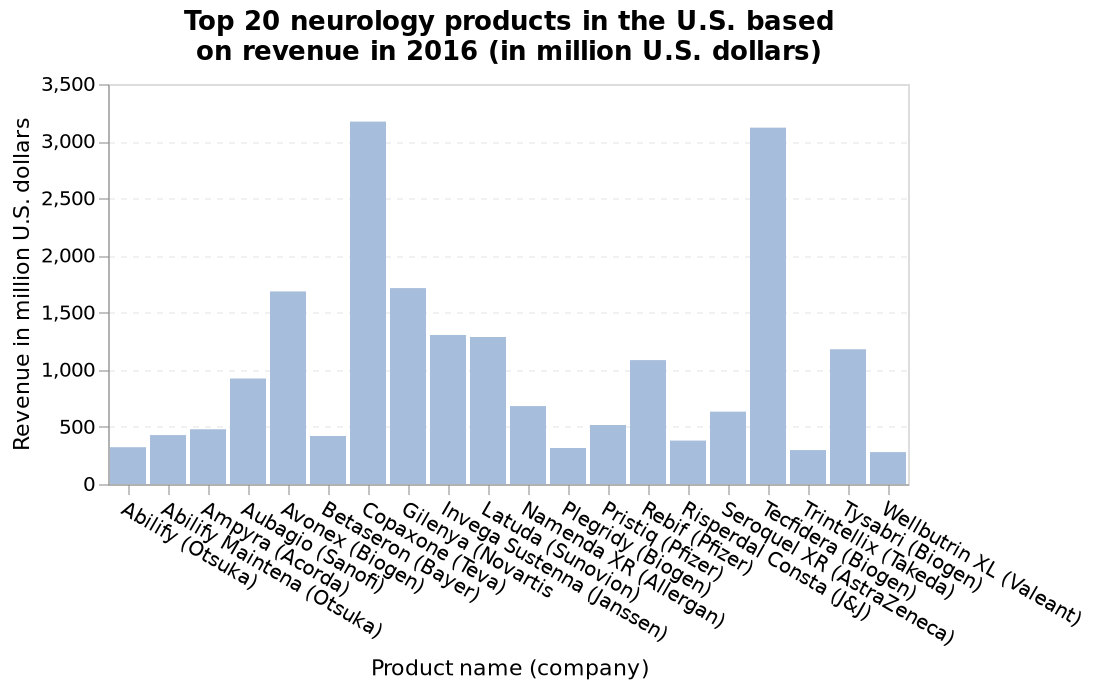<image>
Which company had the lowest revenue in 2016?  Plegridy (Biogen) had the lowest revenue in 2016. 